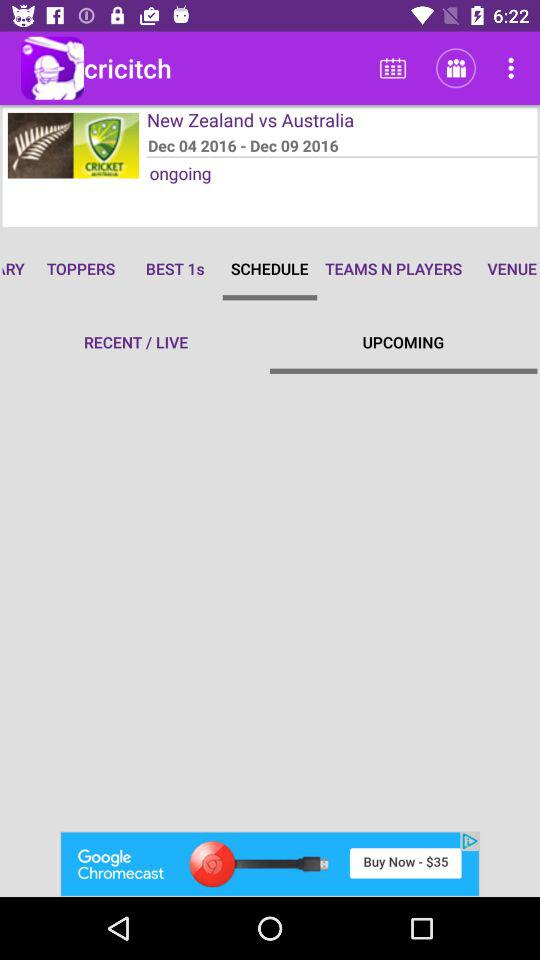What is the name of the application? The name of the application is "cricitch". 